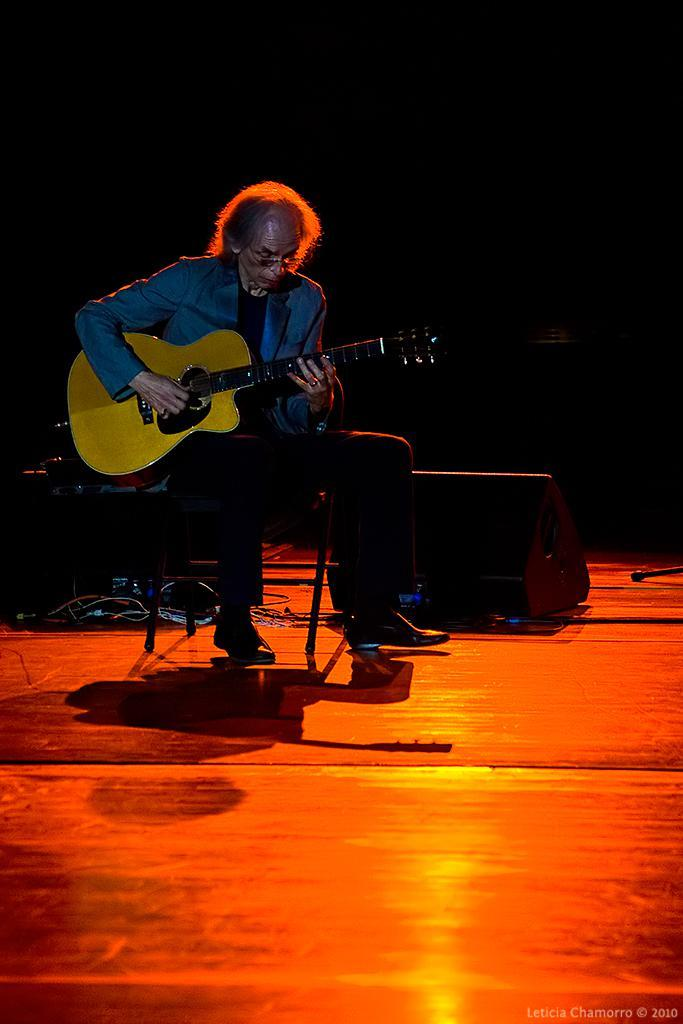Who is the main subject in the image? There is a man in the image. What is the man doing in the image? The man is sitting in a chair and playing a guitar. Where is the man located in the image? The man is on a stage. What object is placed behind the man? There is a box placed behind the man. How would you describe the lighting in the image? The background of the image is dark. How does the man express regret during his performance in the image? There is no indication of regret in the image; the man is simply playing a guitar on stage. 